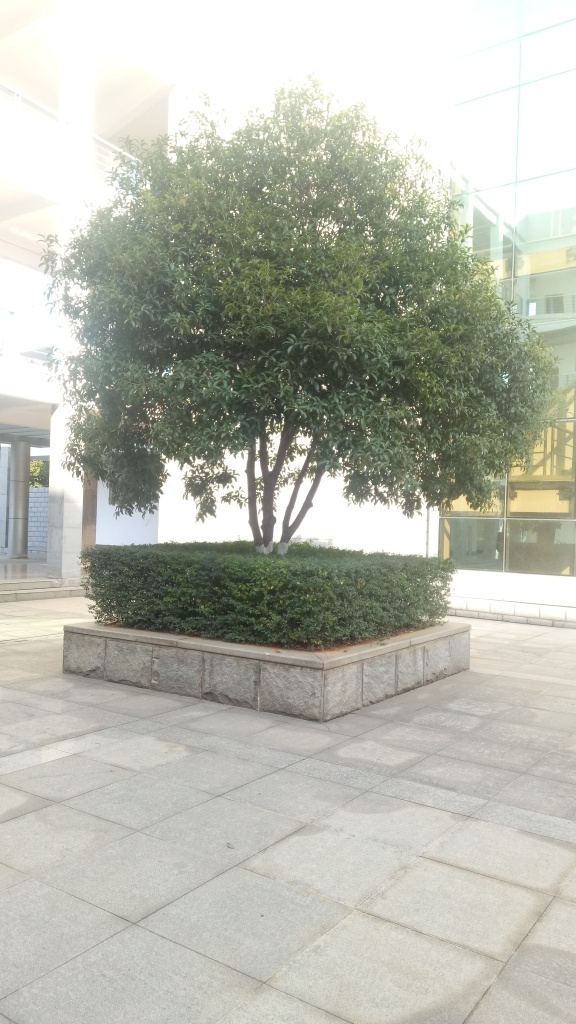Does this scene provide any indication of the location? While there are no explicit landmarks present, the architecture style of the building in the background, the design of the paving, and the species of the tree can hint at a modern, urban space, possibly within a temperate climate zone. The overall maintenance and neatness suggest a well-kept, possibly corporate or public environment. Can the image provide any insight into the season or weather conditions? The lush green leaves indicate that it's likely spring or summer. The clear sky and the absence of any fallen leaves or snow denote fair weather conditions at the time the photo was taken. 